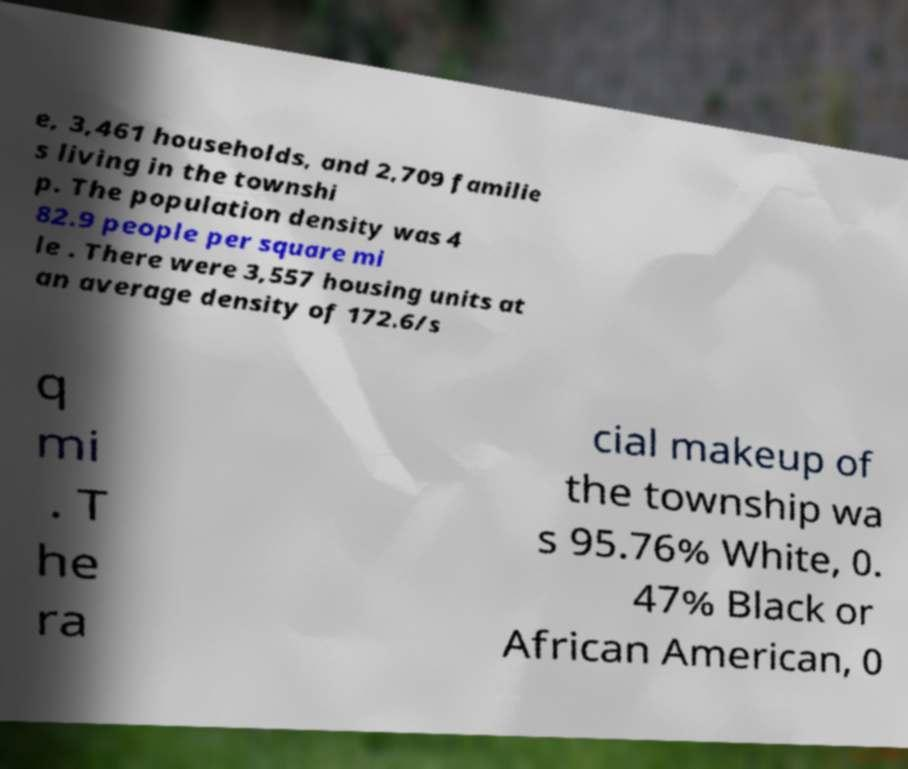Please identify and transcribe the text found in this image. e, 3,461 households, and 2,709 familie s living in the townshi p. The population density was 4 82.9 people per square mi le . There were 3,557 housing units at an average density of 172.6/s q mi . T he ra cial makeup of the township wa s 95.76% White, 0. 47% Black or African American, 0 